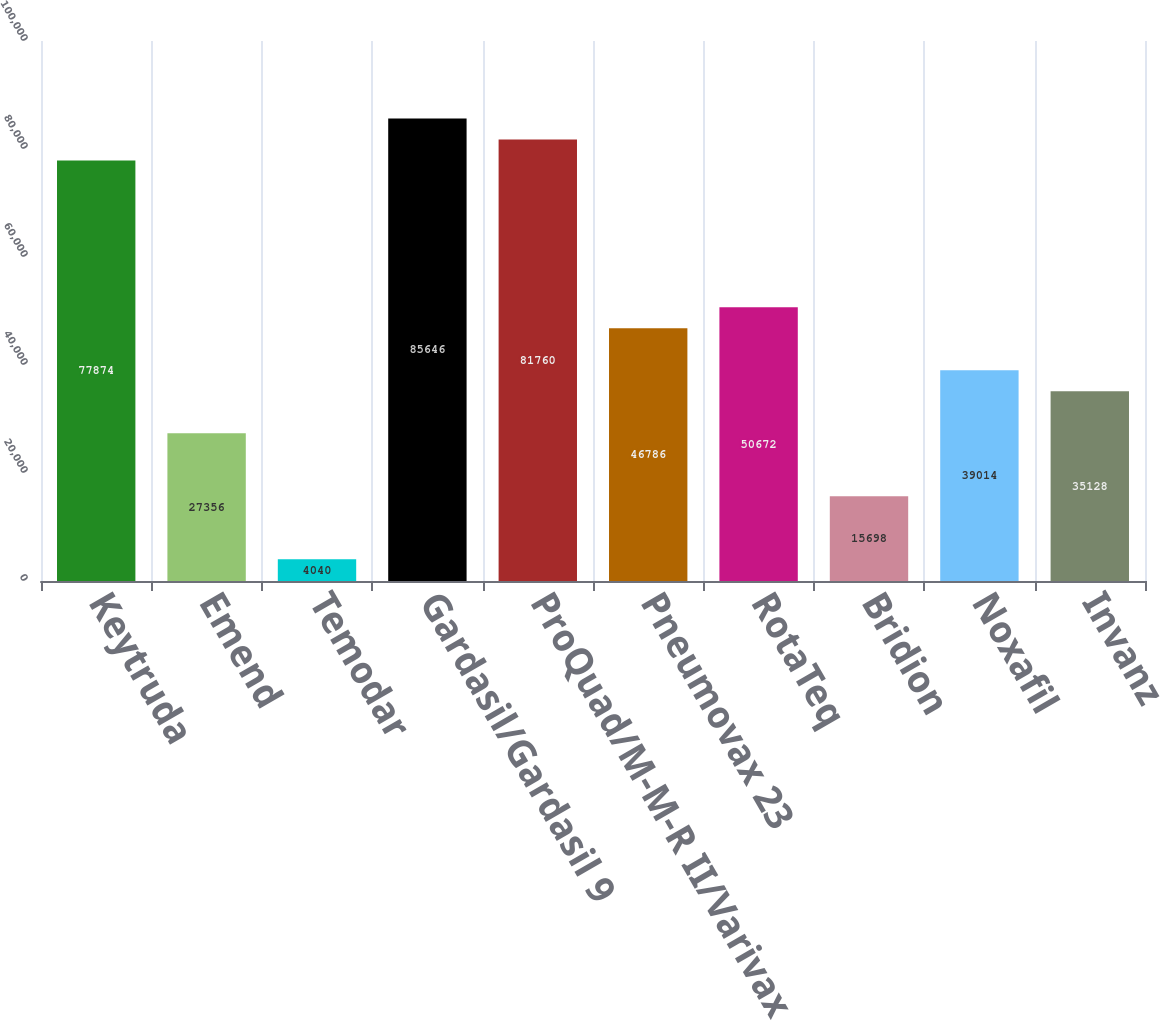<chart> <loc_0><loc_0><loc_500><loc_500><bar_chart><fcel>Keytruda<fcel>Emend<fcel>Temodar<fcel>Gardasil/Gardasil 9<fcel>ProQuad/M-M-R II/Varivax<fcel>Pneumovax 23<fcel>RotaTeq<fcel>Bridion<fcel>Noxafil<fcel>Invanz<nl><fcel>77874<fcel>27356<fcel>4040<fcel>85646<fcel>81760<fcel>46786<fcel>50672<fcel>15698<fcel>39014<fcel>35128<nl></chart> 